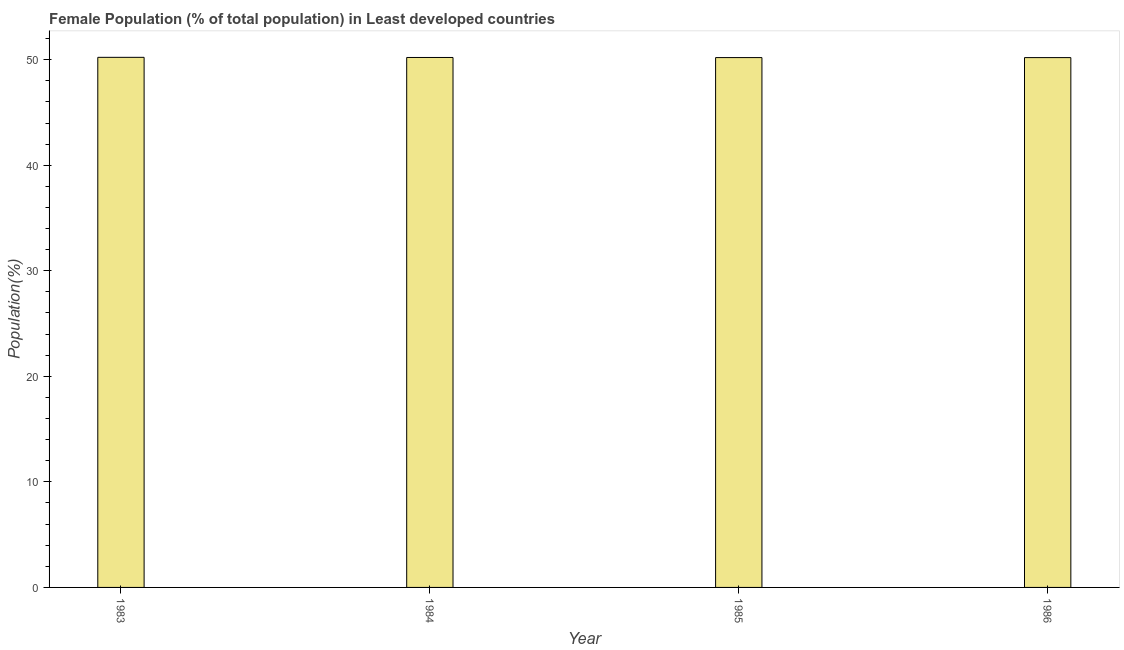Does the graph contain any zero values?
Your response must be concise. No. What is the title of the graph?
Your answer should be compact. Female Population (% of total population) in Least developed countries. What is the label or title of the Y-axis?
Offer a terse response. Population(%). What is the female population in 1983?
Your answer should be compact. 50.22. Across all years, what is the maximum female population?
Keep it short and to the point. 50.22. Across all years, what is the minimum female population?
Make the answer very short. 50.2. In which year was the female population maximum?
Provide a succinct answer. 1983. What is the sum of the female population?
Keep it short and to the point. 200.82. What is the difference between the female population in 1984 and 1985?
Offer a terse response. 0.01. What is the average female population per year?
Your answer should be very brief. 50.21. What is the median female population?
Your answer should be very brief. 50.2. In how many years, is the female population greater than 48 %?
Ensure brevity in your answer.  4. Do a majority of the years between 1986 and 1983 (inclusive) have female population greater than 18 %?
Offer a terse response. Yes. What is the ratio of the female population in 1983 to that in 1984?
Offer a terse response. 1. What is the difference between the highest and the second highest female population?
Your answer should be very brief. 0.01. How many bars are there?
Your answer should be very brief. 4. Are all the bars in the graph horizontal?
Keep it short and to the point. No. What is the difference between two consecutive major ticks on the Y-axis?
Offer a very short reply. 10. What is the Population(%) of 1983?
Offer a terse response. 50.22. What is the Population(%) in 1984?
Your answer should be compact. 50.21. What is the Population(%) in 1985?
Your answer should be very brief. 50.2. What is the Population(%) of 1986?
Make the answer very short. 50.2. What is the difference between the Population(%) in 1983 and 1984?
Provide a short and direct response. 0.01. What is the difference between the Population(%) in 1983 and 1985?
Ensure brevity in your answer.  0.02. What is the difference between the Population(%) in 1983 and 1986?
Offer a very short reply. 0.03. What is the difference between the Population(%) in 1984 and 1985?
Your response must be concise. 0.01. What is the difference between the Population(%) in 1984 and 1986?
Offer a very short reply. 0.01. What is the difference between the Population(%) in 1985 and 1986?
Ensure brevity in your answer.  0. What is the ratio of the Population(%) in 1984 to that in 1985?
Offer a terse response. 1. What is the ratio of the Population(%) in 1985 to that in 1986?
Give a very brief answer. 1. 